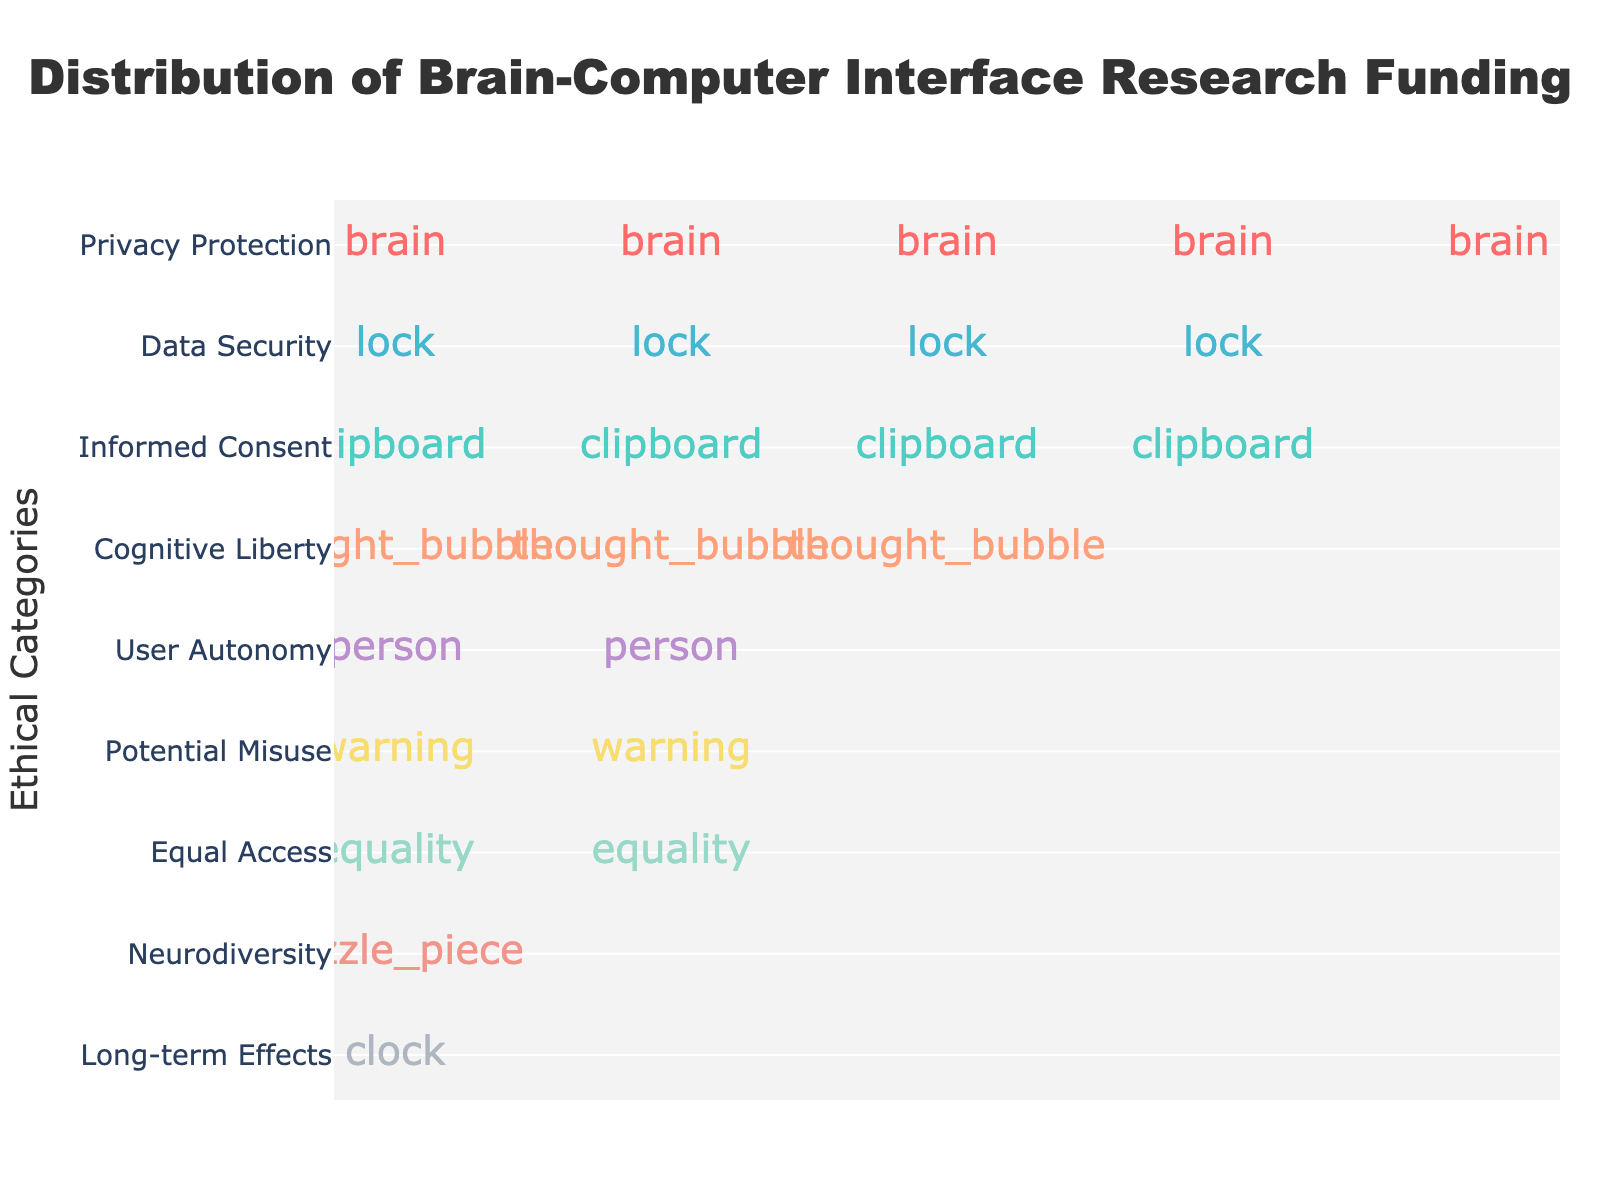what is the category with the highest funding? By observing the plot, you can see that the category 'Privacy Protection' has the most icons. Each icon represents units of funding, implying the highest value allocated.
Answer: Privacy Protection How many brain icons are representing the Privacy Protection category? Each icon represents 5 units. By counting the number of brain icons for 'Privacy Protection' in the plot, you can determine the total number of icons.
Answer: 5 What is the sum of funding values for 'User Autonomy' and 'Data Security' categories? Funding for 'User Autonomy' is 8 and for 'Data Security' is 18. Adding them gives 8 + 18 = 26
Answer: 26 Which category has less funding: 'Equal Access' or 'Cognitive Liberty'? By comparing the icons for 'Equal Access' and 'Cognitive Liberty,' 'Equal Access' has fewer icons, indicating less funding.
Answer: Equal Access What is the average funding value across all categories? Sum all categories' values: 25 + 20 + 18 + 15 + 12 + 10 + 8 + 7 + 5 = 120. There are 9 categories. The average is 120 / 9 ≈ 13.33
Answer: 13.33 Which categories have an equal number of icons on the plot? Comparing the icons for each category, 'Informed Consent' and 'Data Security' both have 4 icons each.
Answer: Informed Consent and Data Security What is the funding difference between the categories with the highest and lowest funding? The highest funding is for 'Privacy Protection' (25) and the lowest is for 'Neurodiversity' (5). The difference is 25 - 5 = 20
Answer: 20 How are the icons for different categories visually distinguished? Each category is represented by a unique icon, and colors are used to differentiate them visually. For instance, 'Privacy Protection' uses a brain icon and so on.
Answer: Different icons and colors 